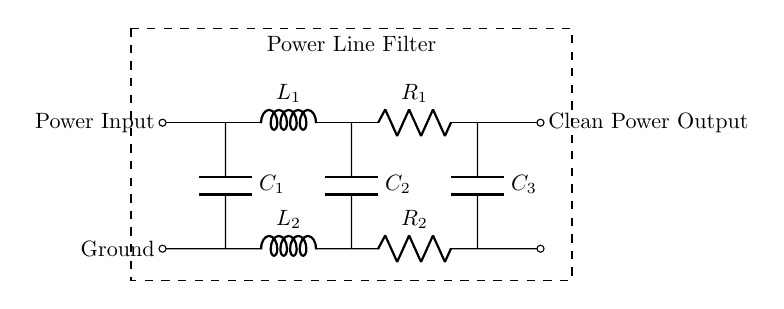What is the main function of this circuit? This circuit is designed as a power line filter, which helps to maintain a clean power supply free from noise and disturbances for sensitive quality control instruments.
Answer: power line filter How many inductors are present in this circuit? There are two inductors labeled L1 and L2 located on the top and bottom paths of the circuit.
Answer: two What components are used to filter the power line? The components used in the power line filtering process are two inductors (L1 and L2), three capacitors (C1, C2, C3), and two resistors (R1 and R2).
Answer: inductors, capacitors, resistors What is the placement of the components in relation to the power input? The components L1 and C1 are immediately connected to the power input, followed by R1 and C2, with the clean power output on the right side of the circuit.
Answer: L1, C1, R1, C2 What does R1 represent in this circuit? R1 represents a resistor that is used in the upper branch of the filter circuit, typically to help reduce unwanted high-frequency noise from the power supply.
Answer: resistor Which components are used for bypassing high frequencies? The capacitors C1, C2, and C3 are placed in this circuit to bypass high-frequency noise to ground, providing a cleaner voltage for sensitive equipment.
Answer: capacitors 